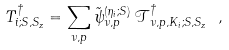Convert formula to latex. <formula><loc_0><loc_0><loc_500><loc_500>T _ { i ; S , S _ { z } } ^ { \dag } = \sum _ { \nu , p } \tilde { \psi } _ { \nu , p } ^ { ( \eta _ { i } ; S ) } \, \mathcal { T } _ { \nu , p , K _ { i } ; S , S _ { z } } ^ { \dag } \ ,</formula> 